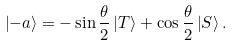<formula> <loc_0><loc_0><loc_500><loc_500>\left | - a \right \rangle = - \sin \frac { \theta } { 2 } \left | T \right \rangle + \cos \frac { \theta } { 2 } \left | S \right \rangle .</formula> 